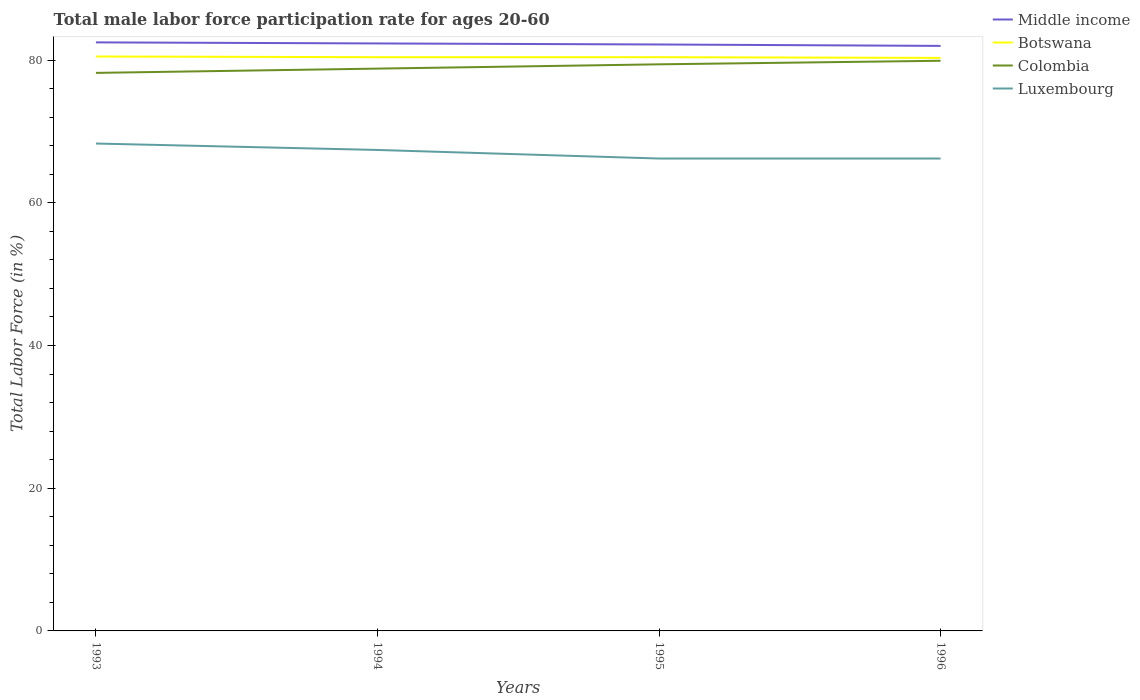Does the line corresponding to Middle income intersect with the line corresponding to Colombia?
Your answer should be very brief. No. Is the number of lines equal to the number of legend labels?
Provide a short and direct response. Yes. Across all years, what is the maximum male labor force participation rate in Botswana?
Ensure brevity in your answer.  80.3. In which year was the male labor force participation rate in Luxembourg maximum?
Make the answer very short. 1995. What is the total male labor force participation rate in Botswana in the graph?
Your answer should be very brief. 0.1. What is the difference between the highest and the second highest male labor force participation rate in Middle income?
Provide a succinct answer. 0.49. Is the male labor force participation rate in Luxembourg strictly greater than the male labor force participation rate in Middle income over the years?
Your response must be concise. Yes. How many lines are there?
Offer a very short reply. 4. How many years are there in the graph?
Your answer should be very brief. 4. Are the values on the major ticks of Y-axis written in scientific E-notation?
Offer a very short reply. No. Does the graph contain any zero values?
Your answer should be very brief. No. How are the legend labels stacked?
Provide a succinct answer. Vertical. What is the title of the graph?
Offer a very short reply. Total male labor force participation rate for ages 20-60. What is the label or title of the X-axis?
Provide a succinct answer. Years. What is the Total Labor Force (in %) of Middle income in 1993?
Keep it short and to the point. 82.48. What is the Total Labor Force (in %) in Botswana in 1993?
Offer a terse response. 80.5. What is the Total Labor Force (in %) of Colombia in 1993?
Offer a terse response. 78.2. What is the Total Labor Force (in %) in Luxembourg in 1993?
Offer a very short reply. 68.3. What is the Total Labor Force (in %) in Middle income in 1994?
Provide a succinct answer. 82.33. What is the Total Labor Force (in %) in Botswana in 1994?
Offer a terse response. 80.4. What is the Total Labor Force (in %) in Colombia in 1994?
Offer a very short reply. 78.8. What is the Total Labor Force (in %) in Luxembourg in 1994?
Ensure brevity in your answer.  67.4. What is the Total Labor Force (in %) of Middle income in 1995?
Offer a very short reply. 82.18. What is the Total Labor Force (in %) of Botswana in 1995?
Give a very brief answer. 80.4. What is the Total Labor Force (in %) of Colombia in 1995?
Offer a very short reply. 79.4. What is the Total Labor Force (in %) of Luxembourg in 1995?
Provide a succinct answer. 66.2. What is the Total Labor Force (in %) of Middle income in 1996?
Offer a very short reply. 81.98. What is the Total Labor Force (in %) in Botswana in 1996?
Your response must be concise. 80.3. What is the Total Labor Force (in %) in Colombia in 1996?
Your answer should be compact. 79.9. What is the Total Labor Force (in %) in Luxembourg in 1996?
Make the answer very short. 66.2. Across all years, what is the maximum Total Labor Force (in %) in Middle income?
Provide a short and direct response. 82.48. Across all years, what is the maximum Total Labor Force (in %) in Botswana?
Provide a succinct answer. 80.5. Across all years, what is the maximum Total Labor Force (in %) of Colombia?
Your response must be concise. 79.9. Across all years, what is the maximum Total Labor Force (in %) in Luxembourg?
Your response must be concise. 68.3. Across all years, what is the minimum Total Labor Force (in %) of Middle income?
Offer a terse response. 81.98. Across all years, what is the minimum Total Labor Force (in %) in Botswana?
Make the answer very short. 80.3. Across all years, what is the minimum Total Labor Force (in %) in Colombia?
Ensure brevity in your answer.  78.2. Across all years, what is the minimum Total Labor Force (in %) of Luxembourg?
Give a very brief answer. 66.2. What is the total Total Labor Force (in %) of Middle income in the graph?
Ensure brevity in your answer.  328.97. What is the total Total Labor Force (in %) of Botswana in the graph?
Provide a short and direct response. 321.6. What is the total Total Labor Force (in %) of Colombia in the graph?
Provide a succinct answer. 316.3. What is the total Total Labor Force (in %) in Luxembourg in the graph?
Your answer should be very brief. 268.1. What is the difference between the Total Labor Force (in %) in Middle income in 1993 and that in 1994?
Offer a terse response. 0.15. What is the difference between the Total Labor Force (in %) in Botswana in 1993 and that in 1994?
Your response must be concise. 0.1. What is the difference between the Total Labor Force (in %) of Colombia in 1993 and that in 1994?
Give a very brief answer. -0.6. What is the difference between the Total Labor Force (in %) of Luxembourg in 1993 and that in 1994?
Give a very brief answer. 0.9. What is the difference between the Total Labor Force (in %) of Middle income in 1993 and that in 1995?
Keep it short and to the point. 0.29. What is the difference between the Total Labor Force (in %) in Botswana in 1993 and that in 1995?
Offer a very short reply. 0.1. What is the difference between the Total Labor Force (in %) in Middle income in 1993 and that in 1996?
Give a very brief answer. 0.49. What is the difference between the Total Labor Force (in %) in Luxembourg in 1993 and that in 1996?
Keep it short and to the point. 2.1. What is the difference between the Total Labor Force (in %) in Middle income in 1994 and that in 1995?
Make the answer very short. 0.15. What is the difference between the Total Labor Force (in %) of Colombia in 1994 and that in 1995?
Ensure brevity in your answer.  -0.6. What is the difference between the Total Labor Force (in %) in Luxembourg in 1994 and that in 1995?
Your answer should be very brief. 1.2. What is the difference between the Total Labor Force (in %) in Middle income in 1994 and that in 1996?
Ensure brevity in your answer.  0.34. What is the difference between the Total Labor Force (in %) in Botswana in 1994 and that in 1996?
Make the answer very short. 0.1. What is the difference between the Total Labor Force (in %) of Middle income in 1995 and that in 1996?
Offer a terse response. 0.2. What is the difference between the Total Labor Force (in %) in Botswana in 1995 and that in 1996?
Offer a terse response. 0.1. What is the difference between the Total Labor Force (in %) of Colombia in 1995 and that in 1996?
Keep it short and to the point. -0.5. What is the difference between the Total Labor Force (in %) in Luxembourg in 1995 and that in 1996?
Your answer should be very brief. 0. What is the difference between the Total Labor Force (in %) of Middle income in 1993 and the Total Labor Force (in %) of Botswana in 1994?
Your response must be concise. 2.08. What is the difference between the Total Labor Force (in %) in Middle income in 1993 and the Total Labor Force (in %) in Colombia in 1994?
Your answer should be compact. 3.68. What is the difference between the Total Labor Force (in %) of Middle income in 1993 and the Total Labor Force (in %) of Luxembourg in 1994?
Make the answer very short. 15.08. What is the difference between the Total Labor Force (in %) in Botswana in 1993 and the Total Labor Force (in %) in Colombia in 1994?
Your response must be concise. 1.7. What is the difference between the Total Labor Force (in %) of Botswana in 1993 and the Total Labor Force (in %) of Luxembourg in 1994?
Provide a short and direct response. 13.1. What is the difference between the Total Labor Force (in %) in Colombia in 1993 and the Total Labor Force (in %) in Luxembourg in 1994?
Your answer should be compact. 10.8. What is the difference between the Total Labor Force (in %) in Middle income in 1993 and the Total Labor Force (in %) in Botswana in 1995?
Your answer should be very brief. 2.08. What is the difference between the Total Labor Force (in %) in Middle income in 1993 and the Total Labor Force (in %) in Colombia in 1995?
Your answer should be very brief. 3.08. What is the difference between the Total Labor Force (in %) of Middle income in 1993 and the Total Labor Force (in %) of Luxembourg in 1995?
Give a very brief answer. 16.28. What is the difference between the Total Labor Force (in %) of Botswana in 1993 and the Total Labor Force (in %) of Colombia in 1995?
Keep it short and to the point. 1.1. What is the difference between the Total Labor Force (in %) in Colombia in 1993 and the Total Labor Force (in %) in Luxembourg in 1995?
Your answer should be compact. 12. What is the difference between the Total Labor Force (in %) of Middle income in 1993 and the Total Labor Force (in %) of Botswana in 1996?
Your answer should be very brief. 2.18. What is the difference between the Total Labor Force (in %) in Middle income in 1993 and the Total Labor Force (in %) in Colombia in 1996?
Give a very brief answer. 2.58. What is the difference between the Total Labor Force (in %) of Middle income in 1993 and the Total Labor Force (in %) of Luxembourg in 1996?
Make the answer very short. 16.28. What is the difference between the Total Labor Force (in %) in Botswana in 1993 and the Total Labor Force (in %) in Colombia in 1996?
Keep it short and to the point. 0.6. What is the difference between the Total Labor Force (in %) of Botswana in 1993 and the Total Labor Force (in %) of Luxembourg in 1996?
Your response must be concise. 14.3. What is the difference between the Total Labor Force (in %) in Colombia in 1993 and the Total Labor Force (in %) in Luxembourg in 1996?
Offer a very short reply. 12. What is the difference between the Total Labor Force (in %) in Middle income in 1994 and the Total Labor Force (in %) in Botswana in 1995?
Make the answer very short. 1.93. What is the difference between the Total Labor Force (in %) of Middle income in 1994 and the Total Labor Force (in %) of Colombia in 1995?
Ensure brevity in your answer.  2.93. What is the difference between the Total Labor Force (in %) in Middle income in 1994 and the Total Labor Force (in %) in Luxembourg in 1995?
Make the answer very short. 16.13. What is the difference between the Total Labor Force (in %) of Botswana in 1994 and the Total Labor Force (in %) of Luxembourg in 1995?
Make the answer very short. 14.2. What is the difference between the Total Labor Force (in %) in Colombia in 1994 and the Total Labor Force (in %) in Luxembourg in 1995?
Offer a very short reply. 12.6. What is the difference between the Total Labor Force (in %) in Middle income in 1994 and the Total Labor Force (in %) in Botswana in 1996?
Provide a short and direct response. 2.03. What is the difference between the Total Labor Force (in %) of Middle income in 1994 and the Total Labor Force (in %) of Colombia in 1996?
Offer a very short reply. 2.43. What is the difference between the Total Labor Force (in %) of Middle income in 1994 and the Total Labor Force (in %) of Luxembourg in 1996?
Provide a succinct answer. 16.13. What is the difference between the Total Labor Force (in %) of Colombia in 1994 and the Total Labor Force (in %) of Luxembourg in 1996?
Provide a succinct answer. 12.6. What is the difference between the Total Labor Force (in %) in Middle income in 1995 and the Total Labor Force (in %) in Botswana in 1996?
Ensure brevity in your answer.  1.88. What is the difference between the Total Labor Force (in %) of Middle income in 1995 and the Total Labor Force (in %) of Colombia in 1996?
Provide a short and direct response. 2.28. What is the difference between the Total Labor Force (in %) in Middle income in 1995 and the Total Labor Force (in %) in Luxembourg in 1996?
Give a very brief answer. 15.98. What is the average Total Labor Force (in %) in Middle income per year?
Keep it short and to the point. 82.24. What is the average Total Labor Force (in %) of Botswana per year?
Your answer should be very brief. 80.4. What is the average Total Labor Force (in %) in Colombia per year?
Offer a very short reply. 79.08. What is the average Total Labor Force (in %) in Luxembourg per year?
Offer a very short reply. 67.03. In the year 1993, what is the difference between the Total Labor Force (in %) of Middle income and Total Labor Force (in %) of Botswana?
Provide a short and direct response. 1.98. In the year 1993, what is the difference between the Total Labor Force (in %) of Middle income and Total Labor Force (in %) of Colombia?
Ensure brevity in your answer.  4.28. In the year 1993, what is the difference between the Total Labor Force (in %) in Middle income and Total Labor Force (in %) in Luxembourg?
Your response must be concise. 14.18. In the year 1993, what is the difference between the Total Labor Force (in %) in Botswana and Total Labor Force (in %) in Colombia?
Keep it short and to the point. 2.3. In the year 1993, what is the difference between the Total Labor Force (in %) in Colombia and Total Labor Force (in %) in Luxembourg?
Give a very brief answer. 9.9. In the year 1994, what is the difference between the Total Labor Force (in %) of Middle income and Total Labor Force (in %) of Botswana?
Your answer should be compact. 1.93. In the year 1994, what is the difference between the Total Labor Force (in %) in Middle income and Total Labor Force (in %) in Colombia?
Offer a very short reply. 3.53. In the year 1994, what is the difference between the Total Labor Force (in %) of Middle income and Total Labor Force (in %) of Luxembourg?
Your answer should be very brief. 14.93. In the year 1994, what is the difference between the Total Labor Force (in %) of Botswana and Total Labor Force (in %) of Colombia?
Keep it short and to the point. 1.6. In the year 1995, what is the difference between the Total Labor Force (in %) in Middle income and Total Labor Force (in %) in Botswana?
Make the answer very short. 1.78. In the year 1995, what is the difference between the Total Labor Force (in %) of Middle income and Total Labor Force (in %) of Colombia?
Your response must be concise. 2.78. In the year 1995, what is the difference between the Total Labor Force (in %) in Middle income and Total Labor Force (in %) in Luxembourg?
Provide a short and direct response. 15.98. In the year 1995, what is the difference between the Total Labor Force (in %) of Botswana and Total Labor Force (in %) of Colombia?
Offer a very short reply. 1. In the year 1996, what is the difference between the Total Labor Force (in %) in Middle income and Total Labor Force (in %) in Botswana?
Ensure brevity in your answer.  1.68. In the year 1996, what is the difference between the Total Labor Force (in %) in Middle income and Total Labor Force (in %) in Colombia?
Keep it short and to the point. 2.08. In the year 1996, what is the difference between the Total Labor Force (in %) in Middle income and Total Labor Force (in %) in Luxembourg?
Give a very brief answer. 15.78. What is the ratio of the Total Labor Force (in %) of Middle income in 1993 to that in 1994?
Keep it short and to the point. 1. What is the ratio of the Total Labor Force (in %) of Botswana in 1993 to that in 1994?
Your answer should be very brief. 1. What is the ratio of the Total Labor Force (in %) of Colombia in 1993 to that in 1994?
Give a very brief answer. 0.99. What is the ratio of the Total Labor Force (in %) of Luxembourg in 1993 to that in 1994?
Provide a succinct answer. 1.01. What is the ratio of the Total Labor Force (in %) in Botswana in 1993 to that in 1995?
Offer a very short reply. 1. What is the ratio of the Total Labor Force (in %) in Colombia in 1993 to that in 1995?
Give a very brief answer. 0.98. What is the ratio of the Total Labor Force (in %) in Luxembourg in 1993 to that in 1995?
Ensure brevity in your answer.  1.03. What is the ratio of the Total Labor Force (in %) of Middle income in 1993 to that in 1996?
Ensure brevity in your answer.  1.01. What is the ratio of the Total Labor Force (in %) of Colombia in 1993 to that in 1996?
Your answer should be very brief. 0.98. What is the ratio of the Total Labor Force (in %) of Luxembourg in 1993 to that in 1996?
Give a very brief answer. 1.03. What is the ratio of the Total Labor Force (in %) in Luxembourg in 1994 to that in 1995?
Offer a terse response. 1.02. What is the ratio of the Total Labor Force (in %) in Colombia in 1994 to that in 1996?
Give a very brief answer. 0.99. What is the ratio of the Total Labor Force (in %) in Luxembourg in 1994 to that in 1996?
Your answer should be compact. 1.02. What is the ratio of the Total Labor Force (in %) in Botswana in 1995 to that in 1996?
Provide a short and direct response. 1. What is the ratio of the Total Labor Force (in %) in Luxembourg in 1995 to that in 1996?
Your answer should be compact. 1. What is the difference between the highest and the second highest Total Labor Force (in %) in Middle income?
Your answer should be compact. 0.15. What is the difference between the highest and the second highest Total Labor Force (in %) of Botswana?
Offer a terse response. 0.1. What is the difference between the highest and the lowest Total Labor Force (in %) of Middle income?
Your response must be concise. 0.49. What is the difference between the highest and the lowest Total Labor Force (in %) in Botswana?
Your answer should be compact. 0.2. What is the difference between the highest and the lowest Total Labor Force (in %) of Colombia?
Give a very brief answer. 1.7. 